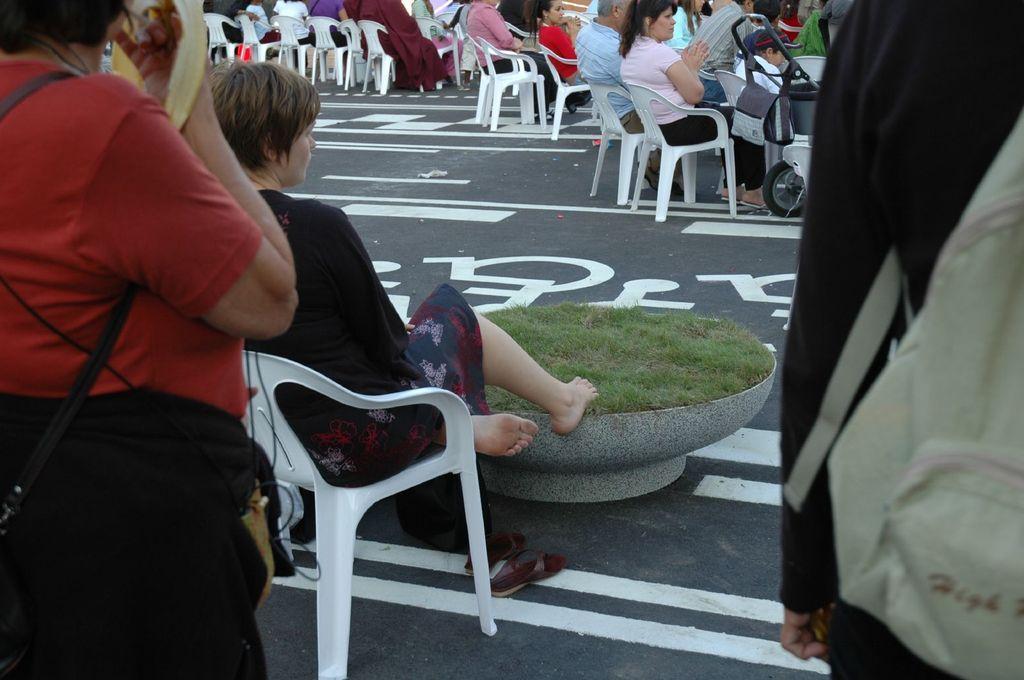Can you describe this image briefly? In this picture, we see many people sitting on chair. On the left corner of the picture, women in red t-shirt is wearing black bag. On the right corner of the picture, woman in black t-shirt is wearing green bag. In the middle of the picture, we see a bowl containing grass, which is placed on the road. 